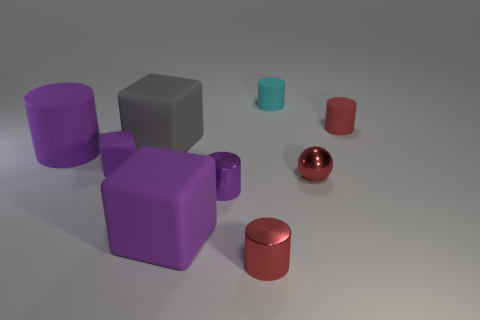Subtract 1 cylinders. How many cylinders are left? 4 Subtract all small red rubber cylinders. How many cylinders are left? 4 Subtract all cyan cylinders. How many cylinders are left? 4 Subtract all gray cylinders. Subtract all yellow blocks. How many cylinders are left? 5 Add 1 tiny red shiny objects. How many objects exist? 10 Subtract all balls. How many objects are left? 8 Subtract all gray cylinders. Subtract all big matte cylinders. How many objects are left? 8 Add 1 red metal balls. How many red metal balls are left? 2 Add 6 small red rubber objects. How many small red rubber objects exist? 7 Subtract 0 cyan blocks. How many objects are left? 9 